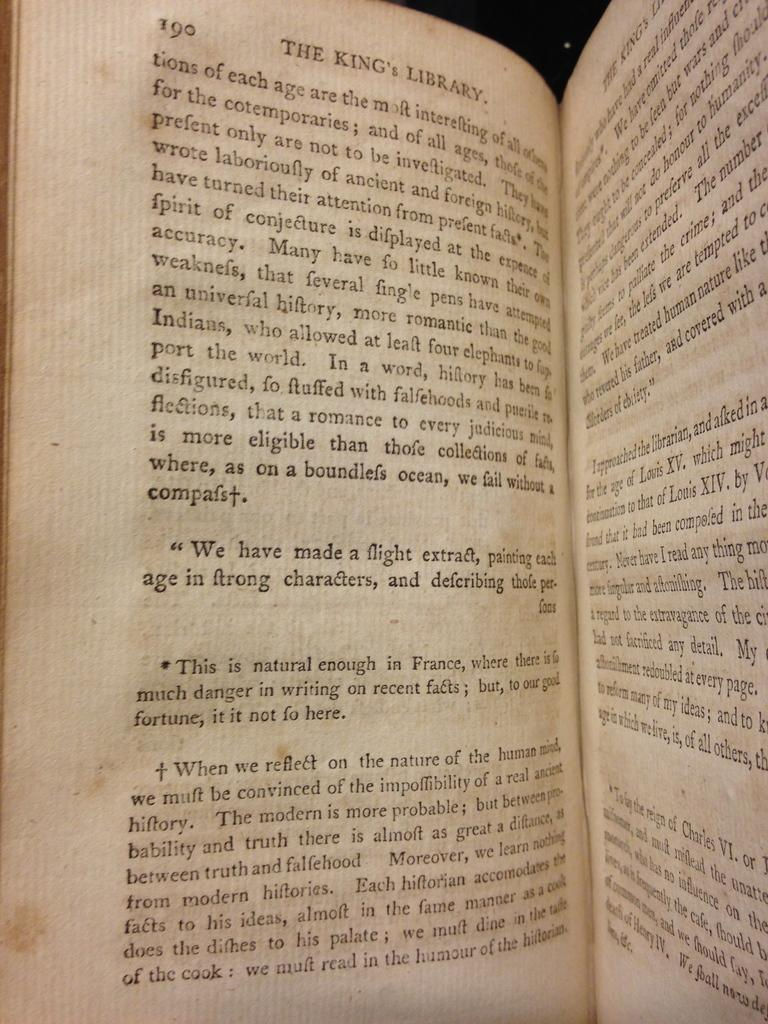<image>
Summarize the visual content of the image. A book called The King's Library is open to page 190. 